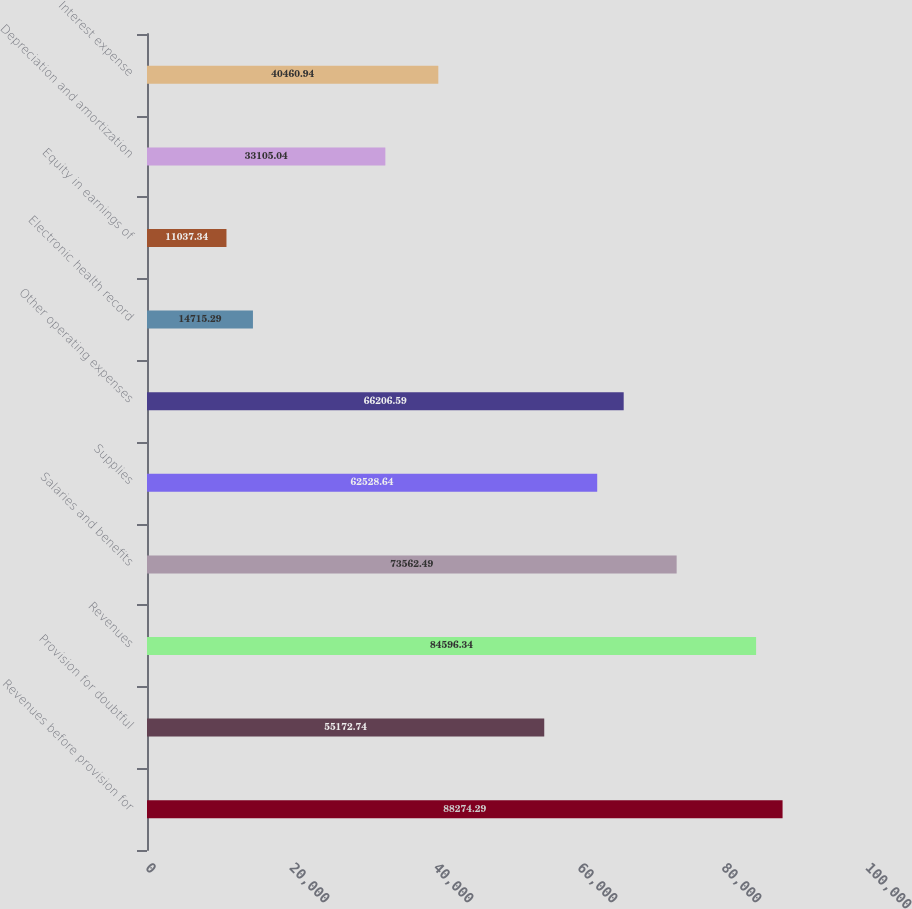Convert chart. <chart><loc_0><loc_0><loc_500><loc_500><bar_chart><fcel>Revenues before provision for<fcel>Provision for doubtful<fcel>Revenues<fcel>Salaries and benefits<fcel>Supplies<fcel>Other operating expenses<fcel>Electronic health record<fcel>Equity in earnings of<fcel>Depreciation and amortization<fcel>Interest expense<nl><fcel>88274.3<fcel>55172.7<fcel>84596.3<fcel>73562.5<fcel>62528.6<fcel>66206.6<fcel>14715.3<fcel>11037.3<fcel>33105<fcel>40460.9<nl></chart> 